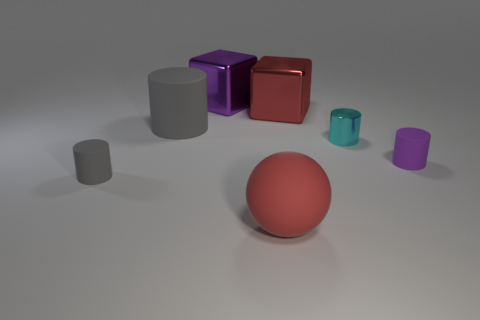Is the material of the big gray cylinder the same as the purple object right of the rubber sphere?
Make the answer very short. Yes. What number of other objects are the same shape as the purple shiny object?
Offer a very short reply. 1. How many objects are big things that are right of the large purple shiny thing or large red things that are behind the small cyan metallic cylinder?
Your answer should be very brief. 2. How many other objects are the same color as the small metal cylinder?
Offer a terse response. 0. Are there fewer large gray objects that are in front of the sphere than tiny metallic cylinders that are on the left side of the cyan object?
Provide a short and direct response. No. How many big red metal things are there?
Your answer should be compact. 1. There is a tiny purple thing that is the same shape as the tiny cyan shiny thing; what material is it?
Provide a succinct answer. Rubber. Are there fewer big shiny cubes that are in front of the purple block than red matte balls?
Offer a terse response. No. Does the small rubber object that is right of the big red sphere have the same shape as the cyan thing?
Keep it short and to the point. Yes. Is there anything else of the same color as the big rubber sphere?
Your response must be concise. Yes. 